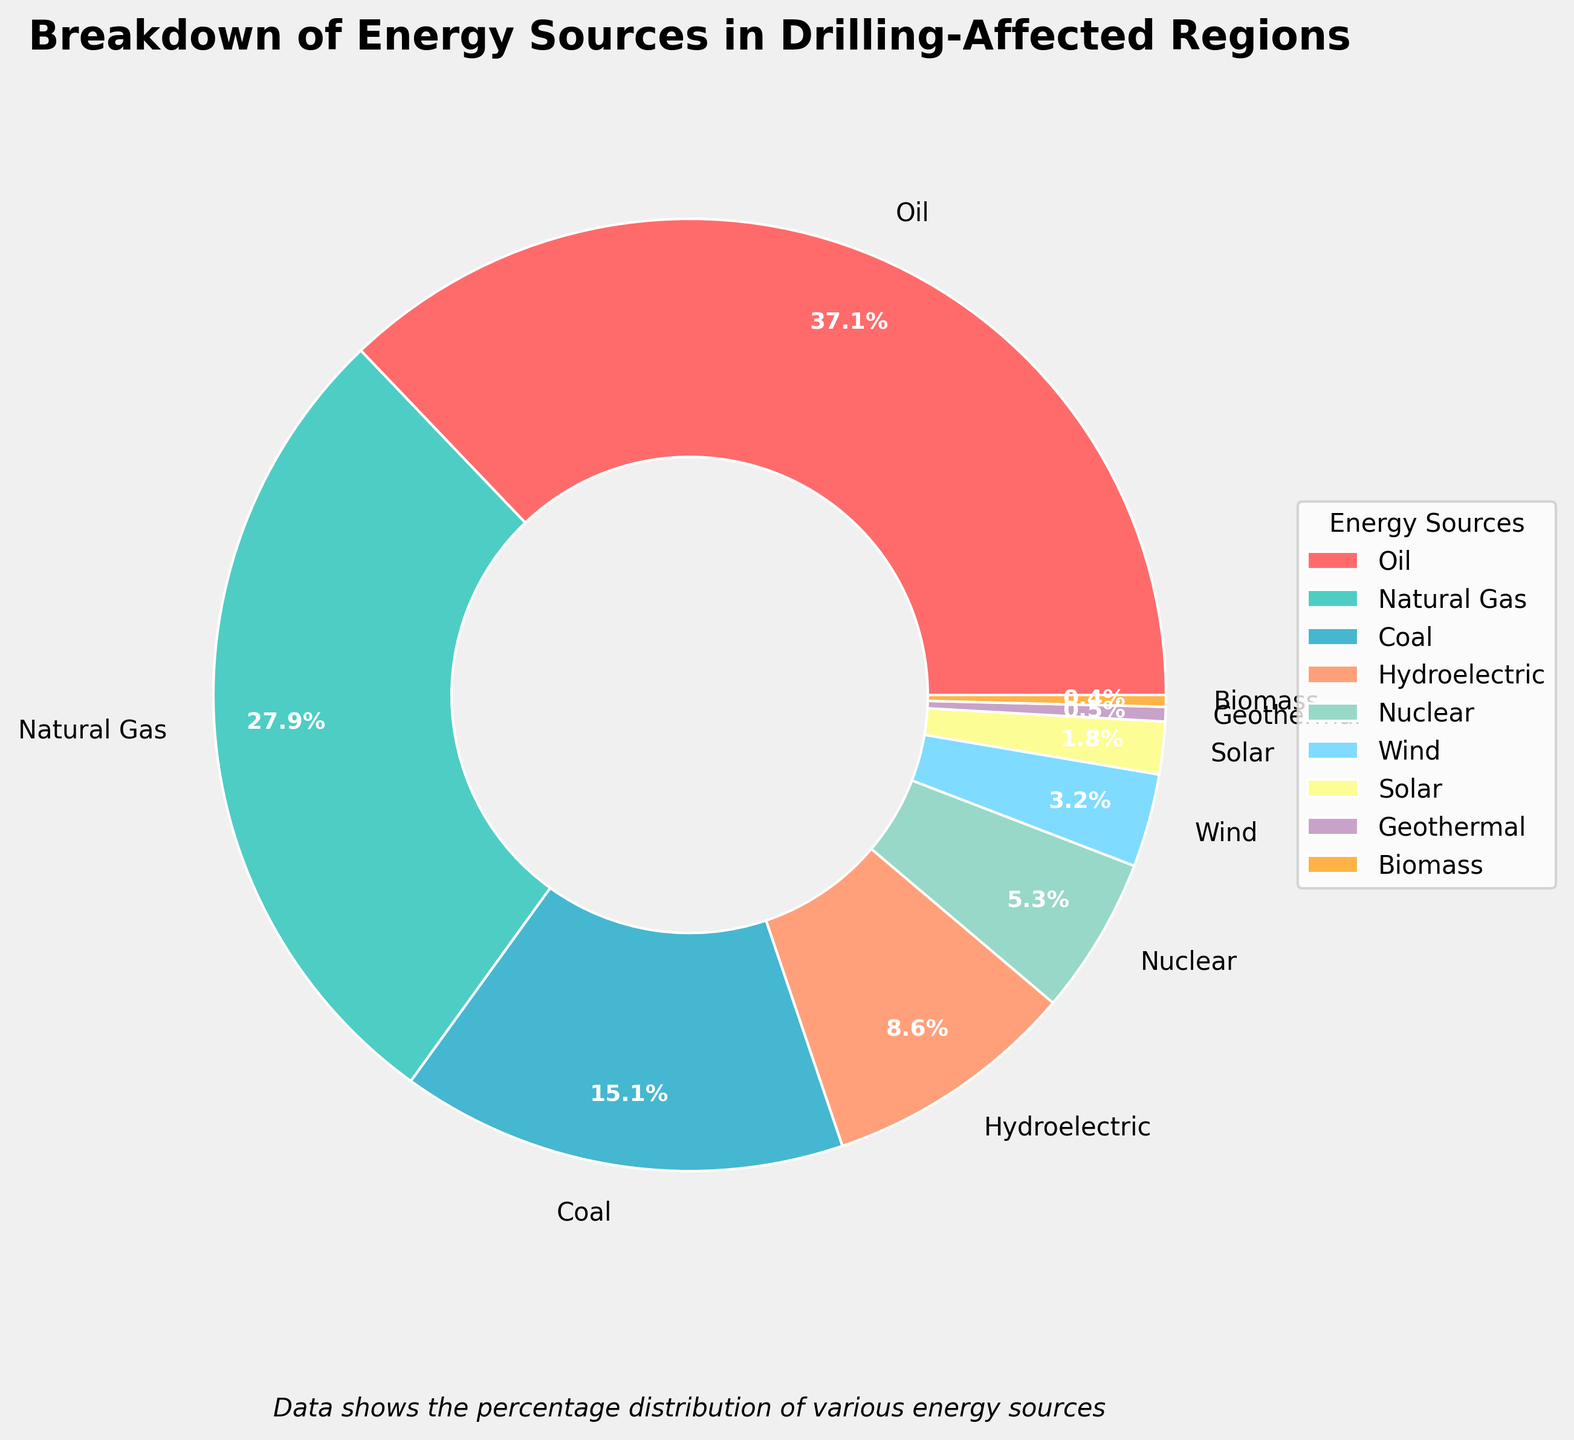What is the most prevalent energy source in drilling-affected regions? The chart shows the percentages of different energy sources. The largest wedge on the pie chart represents oil with 37.5%.
Answer: Oil Which energy source contributes the least to the energy breakdown? According to the chart, the smallest wedge corresponds to biomass, contributing 0.4% of the total energy breakdown.
Answer: Biomass How do the combined contributions of wind and solar compare to nuclear? Combining wind (3.2%) and solar (1.8%) results in 5%. This is slightly less than the contribution from nuclear, which is 5.4%.
Answer: Less than What is the total percentage contributed by renewable energy sources (hydroelectric, wind, solar, geothermal, biomass)? Add the percentages for hydroelectric (8.7%), wind (3.2%), solar (1.8%), geothermal (0.5%), and biomass (0.4%): 8.7 + 3.2 + 1.8 + 0.5 + 0.4 = 14.6%.
Answer: 14.6% Between natural gas and coal, which one is more prevalent and by what percentage difference? Natural gas contributes 28.2%, while coal contributes 15.3%. The difference is 28.2% - 15.3% = 12.9%.
Answer: Natural gas by 12.9% What percentage of the energy breakdown is contributed by non-fossil fuels combined (hydroelectric, nuclear, wind, solar, geothermal, biomass)? Add the contributions: hydroelectric (8.7%), nuclear (5.4%), wind (3.2%), solar (1.8%), geothermal (0.5%), biomass (0.4%): 8.7 + 5.4 + 3.2 + 1.8 + 0.5 + 0.4 = 20%.
Answer: 20% Compare the color of the wedge representing oil to the wedge representing wind. Are they similar or different? The wedge for oil is red, which is a distinctly different color from the light blue color of the wedge representing wind.
Answer: Different Is the sum of the contributions from oil and natural gas more than half of the total energy sources? Oil contributes 37.5% and natural gas 28.2%. Combined, this is 37.5 + 28.2 = 65.7%, which is more than half of the total.
Answer: Yes, more than half What is the difference in percentage between the contributions of nuclear and geothermal? Nuclear contributes 5.4%, and geothermal contributes 0.5%. The difference is 5.4% - 0.5% = 4.9%.
Answer: 4.9% Which energy sources combined make up approximately one-third of the total energy sources? Adding the highest wedges until close to one-third (~33%) are oil (37.5% alone), so moving to smaller wedges: natural gas (28.2%), and coal (15.3%) totals 28.2 + 15.3 = 43.5%, requiring subtraction downwards to get closer to one-third, leading to subtracting oil (37.5%), giving accurate to within small increments.
Answer: Natural Gas and Coal 